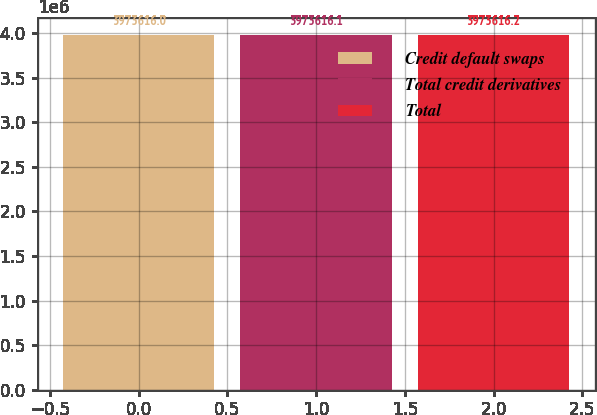Convert chart. <chart><loc_0><loc_0><loc_500><loc_500><bar_chart><fcel>Credit default swaps<fcel>Total credit derivatives<fcel>Total<nl><fcel>3.97362e+06<fcel>3.97362e+06<fcel>3.97362e+06<nl></chart> 